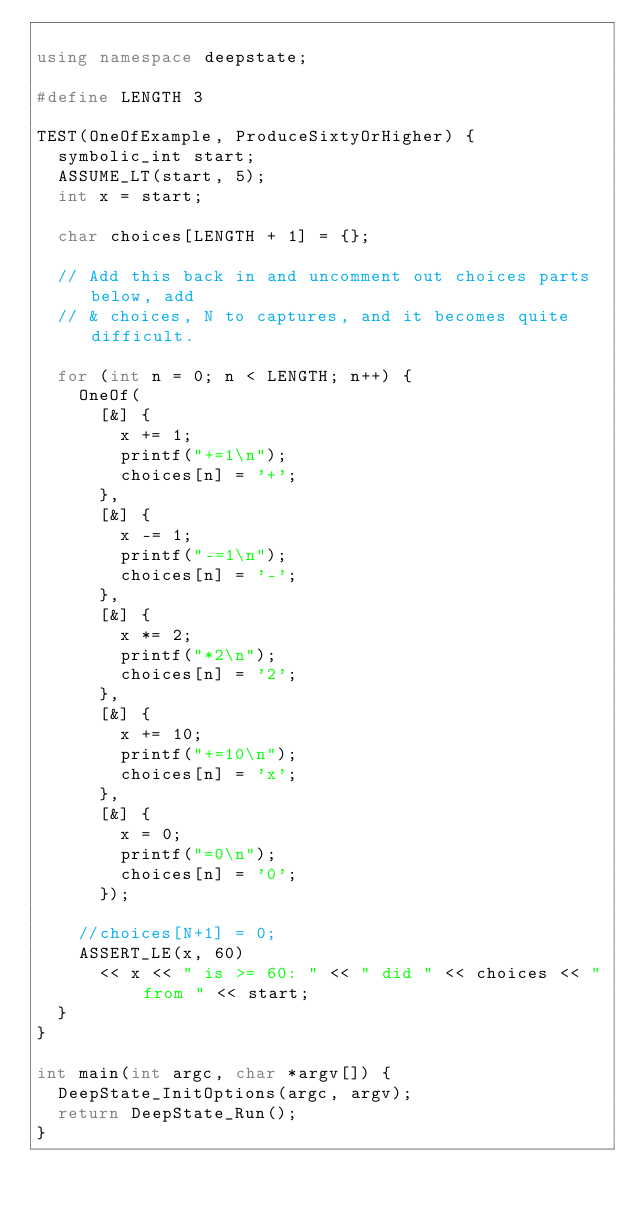Convert code to text. <code><loc_0><loc_0><loc_500><loc_500><_C++_>
using namespace deepstate;

#define LENGTH 3

TEST(OneOfExample, ProduceSixtyOrHigher) {
  symbolic_int start;
  ASSUME_LT(start, 5);
  int x = start;
  
  char choices[LENGTH + 1] = {};
  
  // Add this back in and uncomment out choices parts below, add
  // & choices, N to captures, and it becomes quite difficult.
  
  for (int n = 0; n < LENGTH; n++) {
    OneOf(
      [&] {
        x += 1;
        printf("+=1\n");
        choices[n] = '+';
      },
      [&] {
        x -= 1;
        printf("-=1\n");
        choices[n] = '-';
      },
      [&] {
        x *= 2;
        printf("*2\n");
        choices[n] = '2';
      },
      [&] {
        x += 10;
        printf("+=10\n");
        choices[n] = 'x';
      },
      [&] {
        x = 0;
        printf("=0\n");
        choices[n] = '0';
      });

    //choices[N+1] = 0;
    ASSERT_LE(x, 60)
      << x << " is >= 60: " << " did " << choices << " from " << start;
  }
}

int main(int argc, char *argv[]) {
  DeepState_InitOptions(argc, argv);
  return DeepState_Run();
}
</code> 